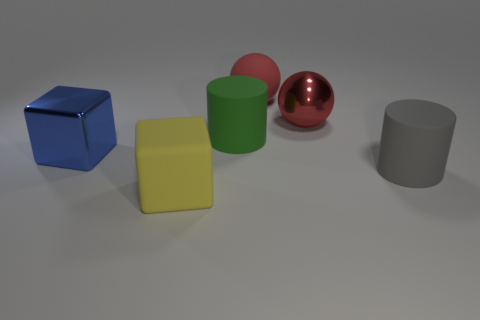What number of red balls are there?
Your answer should be very brief. 2. There is a metal thing that is on the right side of the yellow matte thing; is its shape the same as the big red matte thing?
Your answer should be very brief. Yes. There is a blue cube that is the same size as the green rubber cylinder; what is its material?
Give a very brief answer. Metal. Are there any other yellow cubes made of the same material as the large yellow cube?
Your answer should be compact. No. There is a large gray thing; is it the same shape as the green matte object that is to the left of the gray rubber object?
Keep it short and to the point. Yes. How many matte objects are in front of the large matte sphere and behind the large yellow matte thing?
Give a very brief answer. 2. Do the big yellow cube and the large cylinder behind the large gray matte cylinder have the same material?
Your answer should be compact. Yes. Are there an equal number of big red objects that are in front of the large green matte object and small red cylinders?
Your answer should be compact. Yes. There is a big object left of the yellow thing; what color is it?
Ensure brevity in your answer.  Blue. How many other objects are the same color as the rubber block?
Ensure brevity in your answer.  0. 